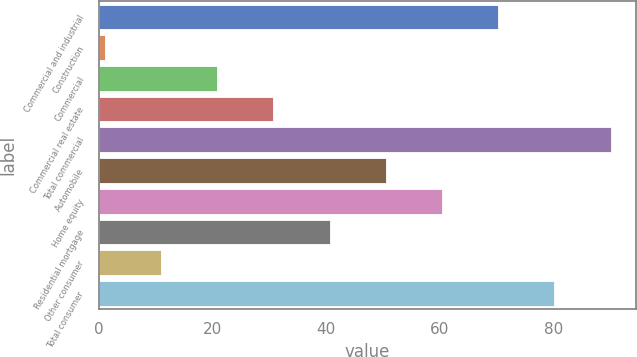Convert chart to OTSL. <chart><loc_0><loc_0><loc_500><loc_500><bar_chart><fcel>Commercial and industrial<fcel>Construction<fcel>Commercial<fcel>Commercial real estate<fcel>Total commercial<fcel>Automobile<fcel>Home equity<fcel>Residential mortgage<fcel>Other consumer<fcel>Total consumer<nl><fcel>70.3<fcel>1<fcel>20.8<fcel>30.7<fcel>90.1<fcel>50.5<fcel>60.4<fcel>40.6<fcel>10.9<fcel>80.2<nl></chart> 